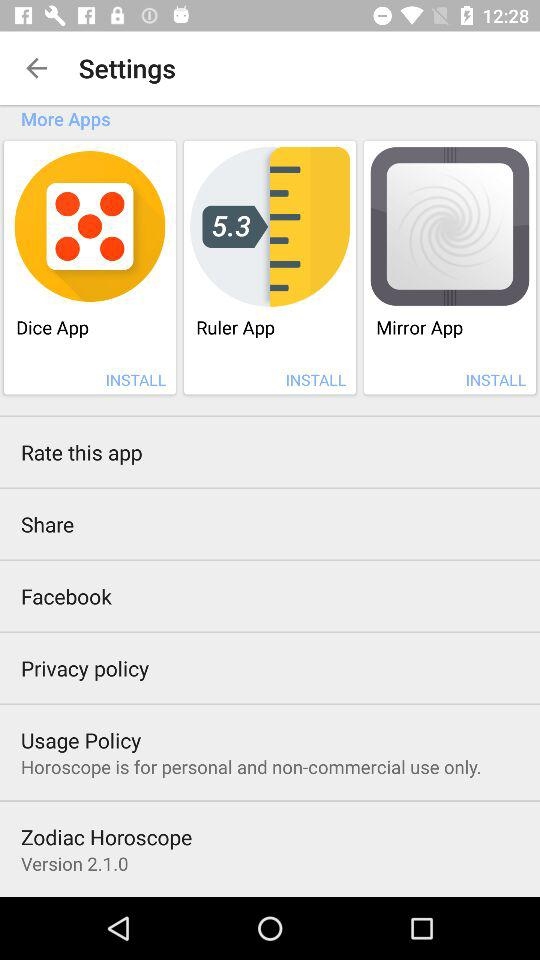What is the version? The version is 2.1.0. 